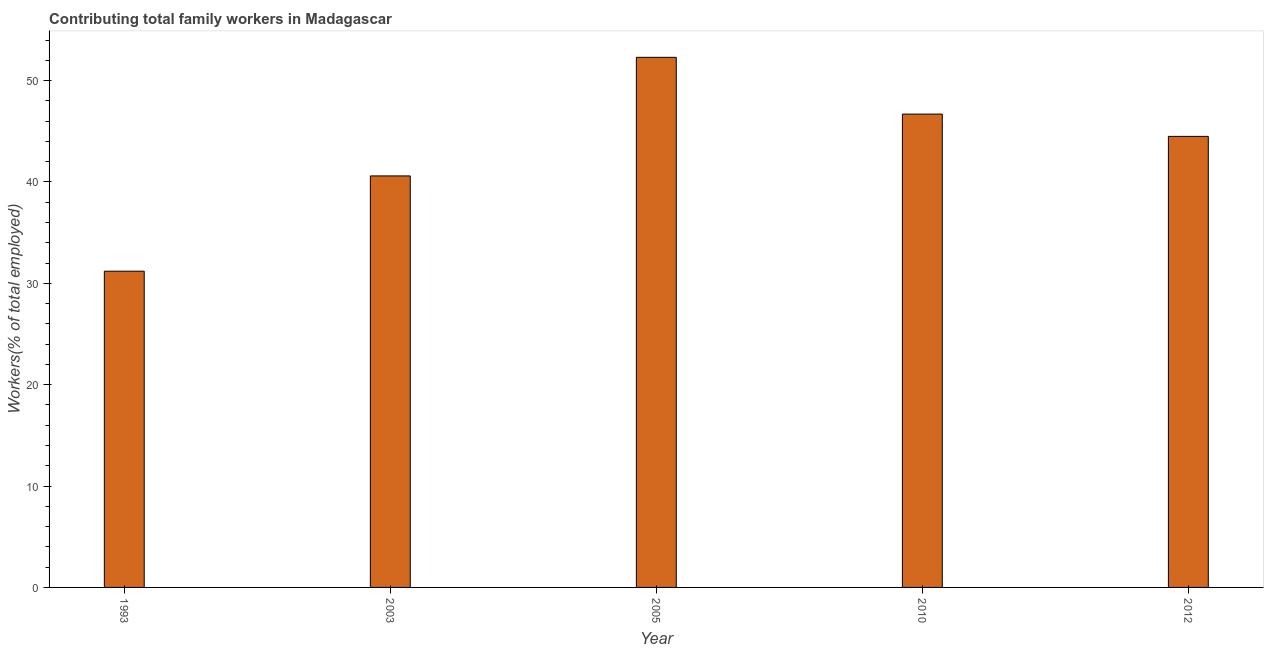Does the graph contain any zero values?
Offer a terse response. No. What is the title of the graph?
Keep it short and to the point. Contributing total family workers in Madagascar. What is the label or title of the Y-axis?
Your answer should be very brief. Workers(% of total employed). What is the contributing family workers in 2005?
Offer a very short reply. 52.3. Across all years, what is the maximum contributing family workers?
Give a very brief answer. 52.3. Across all years, what is the minimum contributing family workers?
Offer a very short reply. 31.2. In which year was the contributing family workers maximum?
Provide a succinct answer. 2005. What is the sum of the contributing family workers?
Give a very brief answer. 215.3. What is the average contributing family workers per year?
Make the answer very short. 43.06. What is the median contributing family workers?
Your response must be concise. 44.5. In how many years, is the contributing family workers greater than 4 %?
Your answer should be very brief. 5. What is the ratio of the contributing family workers in 2003 to that in 2005?
Offer a very short reply. 0.78. What is the difference between the highest and the lowest contributing family workers?
Provide a succinct answer. 21.1. In how many years, is the contributing family workers greater than the average contributing family workers taken over all years?
Your answer should be compact. 3. How many bars are there?
Provide a succinct answer. 5. Are all the bars in the graph horizontal?
Keep it short and to the point. No. What is the difference between two consecutive major ticks on the Y-axis?
Your answer should be very brief. 10. Are the values on the major ticks of Y-axis written in scientific E-notation?
Make the answer very short. No. What is the Workers(% of total employed) in 1993?
Your answer should be compact. 31.2. What is the Workers(% of total employed) of 2003?
Offer a terse response. 40.6. What is the Workers(% of total employed) of 2005?
Make the answer very short. 52.3. What is the Workers(% of total employed) of 2010?
Offer a terse response. 46.7. What is the Workers(% of total employed) in 2012?
Your answer should be compact. 44.5. What is the difference between the Workers(% of total employed) in 1993 and 2005?
Provide a short and direct response. -21.1. What is the difference between the Workers(% of total employed) in 1993 and 2010?
Your answer should be compact. -15.5. What is the difference between the Workers(% of total employed) in 2003 and 2005?
Provide a short and direct response. -11.7. What is the difference between the Workers(% of total employed) in 2003 and 2010?
Offer a very short reply. -6.1. What is the difference between the Workers(% of total employed) in 2003 and 2012?
Offer a terse response. -3.9. What is the difference between the Workers(% of total employed) in 2005 and 2010?
Offer a terse response. 5.6. What is the difference between the Workers(% of total employed) in 2005 and 2012?
Provide a short and direct response. 7.8. What is the difference between the Workers(% of total employed) in 2010 and 2012?
Your response must be concise. 2.2. What is the ratio of the Workers(% of total employed) in 1993 to that in 2003?
Offer a terse response. 0.77. What is the ratio of the Workers(% of total employed) in 1993 to that in 2005?
Keep it short and to the point. 0.6. What is the ratio of the Workers(% of total employed) in 1993 to that in 2010?
Make the answer very short. 0.67. What is the ratio of the Workers(% of total employed) in 1993 to that in 2012?
Offer a terse response. 0.7. What is the ratio of the Workers(% of total employed) in 2003 to that in 2005?
Give a very brief answer. 0.78. What is the ratio of the Workers(% of total employed) in 2003 to that in 2010?
Your answer should be compact. 0.87. What is the ratio of the Workers(% of total employed) in 2003 to that in 2012?
Ensure brevity in your answer.  0.91. What is the ratio of the Workers(% of total employed) in 2005 to that in 2010?
Provide a succinct answer. 1.12. What is the ratio of the Workers(% of total employed) in 2005 to that in 2012?
Provide a succinct answer. 1.18. What is the ratio of the Workers(% of total employed) in 2010 to that in 2012?
Ensure brevity in your answer.  1.05. 